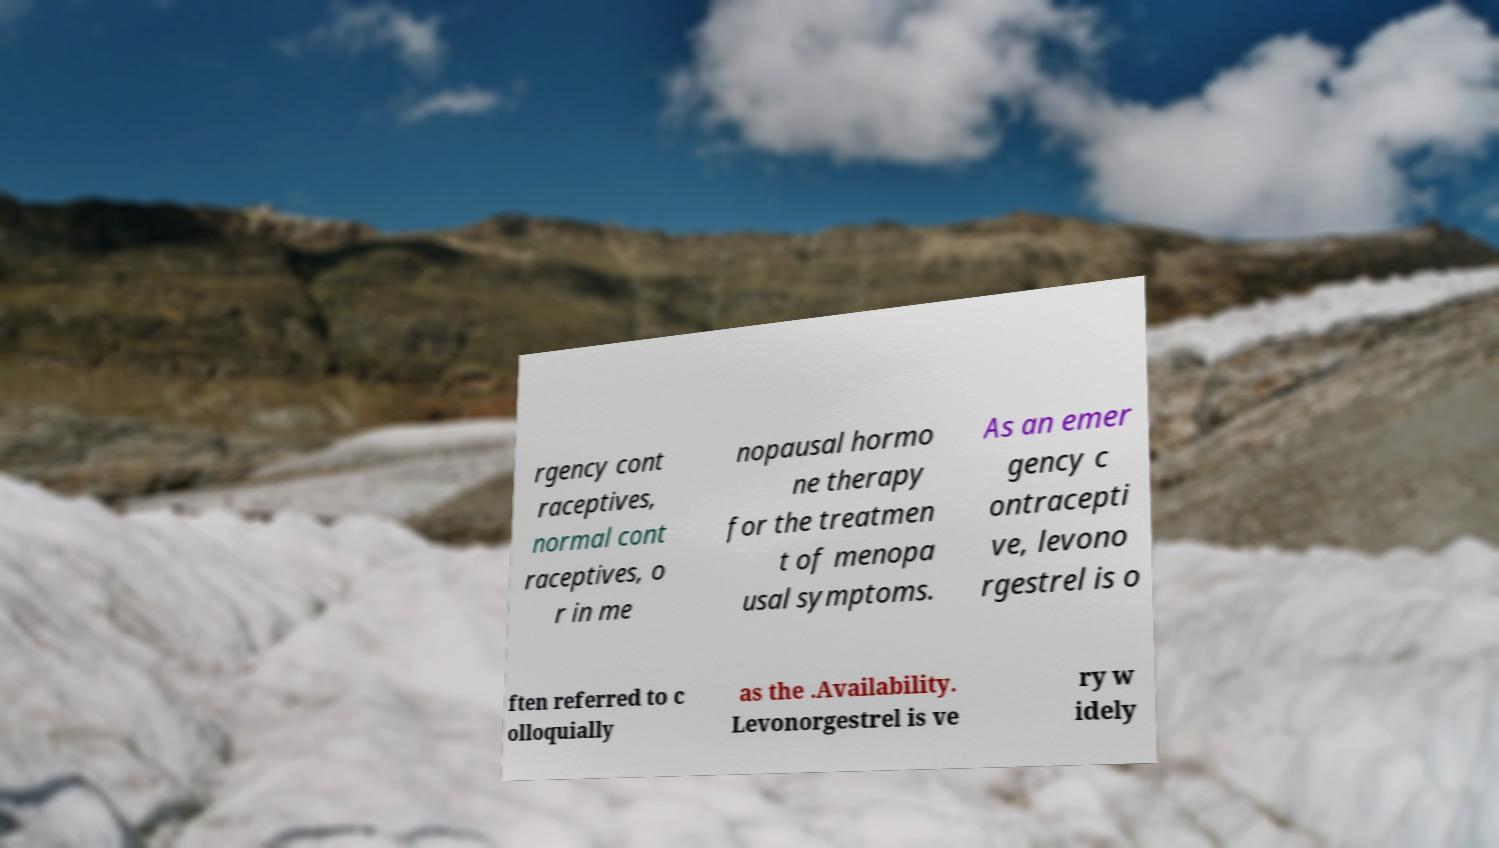Please identify and transcribe the text found in this image. rgency cont raceptives, normal cont raceptives, o r in me nopausal hormo ne therapy for the treatmen t of menopa usal symptoms. As an emer gency c ontracepti ve, levono rgestrel is o ften referred to c olloquially as the .Availability. Levonorgestrel is ve ry w idely 